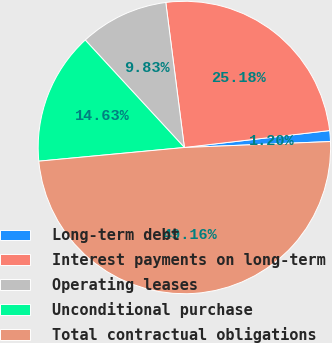Convert chart. <chart><loc_0><loc_0><loc_500><loc_500><pie_chart><fcel>Long-term debt<fcel>Interest payments on long-term<fcel>Operating leases<fcel>Unconditional purchase<fcel>Total contractual obligations<nl><fcel>1.2%<fcel>25.18%<fcel>9.83%<fcel>14.63%<fcel>49.16%<nl></chart> 